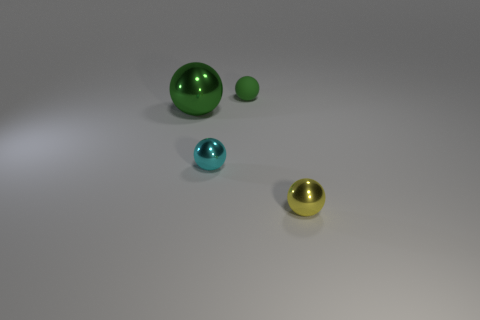Add 3 large green spheres. How many objects exist? 7 Subtract all yellow balls. How many balls are left? 3 Subtract all tiny yellow spheres. How many spheres are left? 3 Subtract all gray spheres. Subtract all blue cubes. How many spheres are left? 4 Subtract 0 brown blocks. How many objects are left? 4 Subtract all red cylinders. Subtract all small green balls. How many objects are left? 3 Add 3 yellow shiny objects. How many yellow shiny objects are left? 4 Add 2 small cyan objects. How many small cyan objects exist? 3 